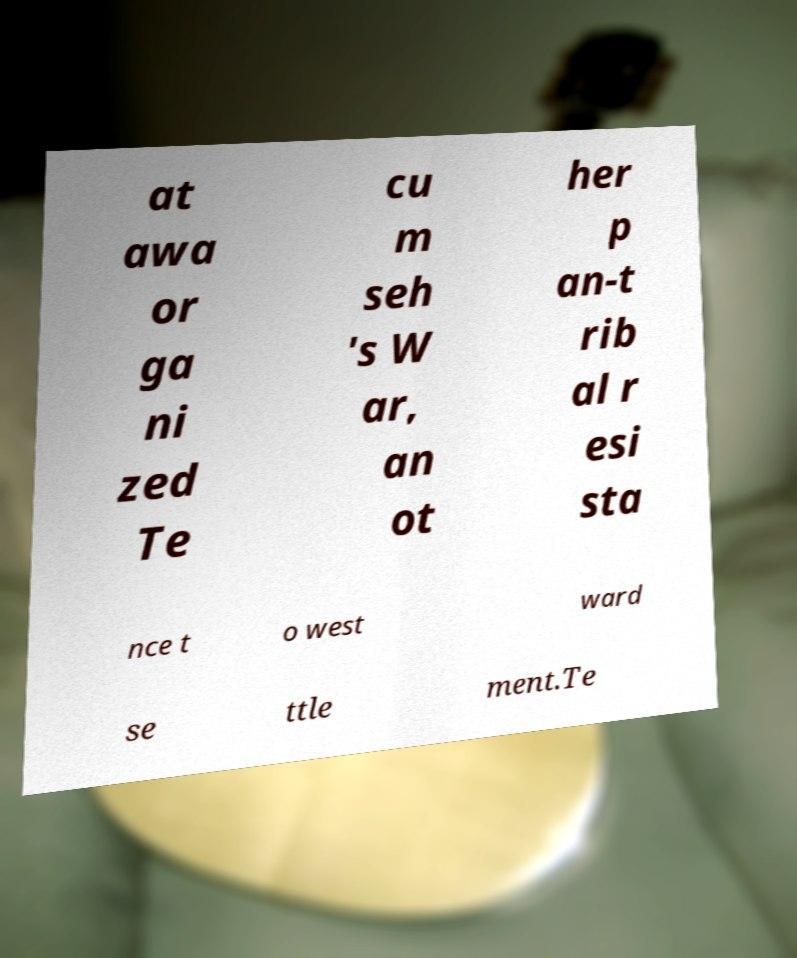What messages or text are displayed in this image? I need them in a readable, typed format. at awa or ga ni zed Te cu m seh 's W ar, an ot her p an-t rib al r esi sta nce t o west ward se ttle ment.Te 